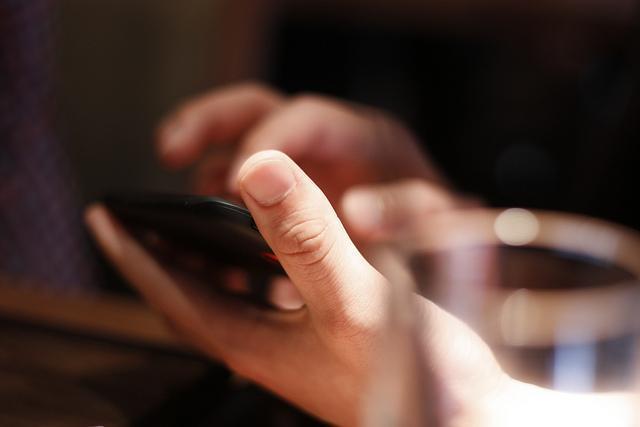How many cell phones are in the picture?
Give a very brief answer. 1. 